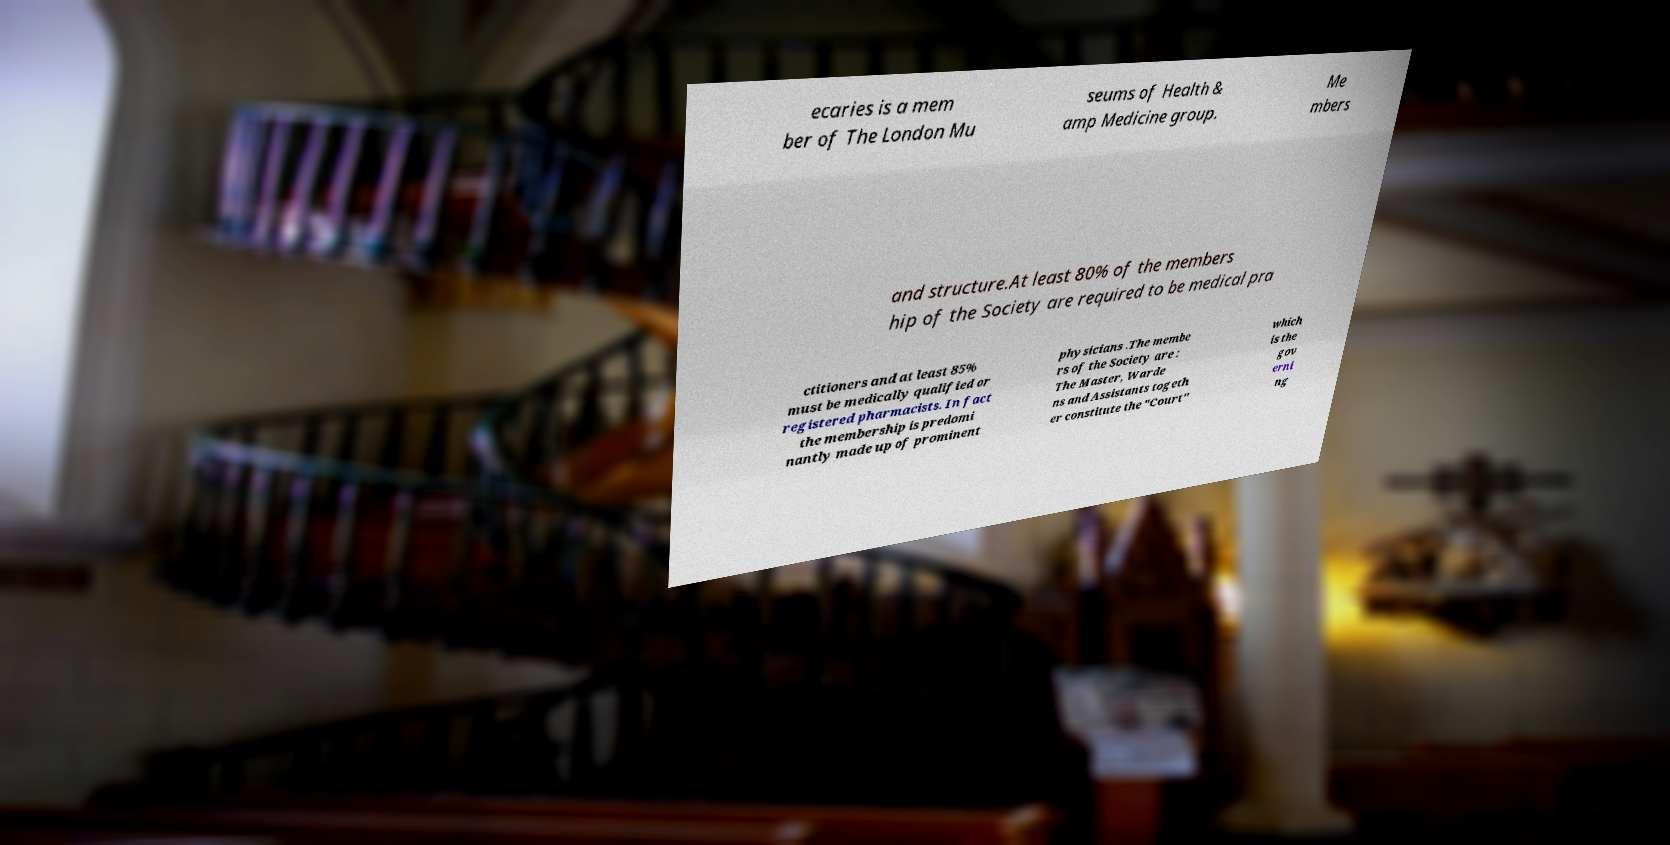Please identify and transcribe the text found in this image. ecaries is a mem ber of The London Mu seums of Health & amp Medicine group. Me mbers and structure.At least 80% of the members hip of the Society are required to be medical pra ctitioners and at least 85% must be medically qualified or registered pharmacists. In fact the membership is predomi nantly made up of prominent physicians .The membe rs of the Society are : The Master, Warde ns and Assistants togeth er constitute the "Court" which is the gov erni ng 